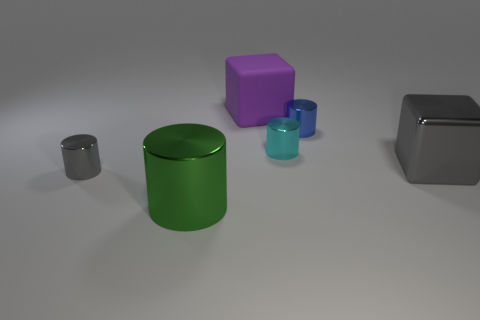Subtract all big green metallic cylinders. How many cylinders are left? 3 Add 3 small objects. How many objects exist? 9 Subtract 2 cylinders. How many cylinders are left? 2 Subtract all cylinders. How many objects are left? 2 Subtract all green cylinders. How many cylinders are left? 3 Subtract all large green cylinders. Subtract all small gray cylinders. How many objects are left? 4 Add 2 purple matte objects. How many purple matte objects are left? 3 Add 2 rubber cubes. How many rubber cubes exist? 3 Subtract 0 brown cylinders. How many objects are left? 6 Subtract all brown cubes. Subtract all red balls. How many cubes are left? 2 